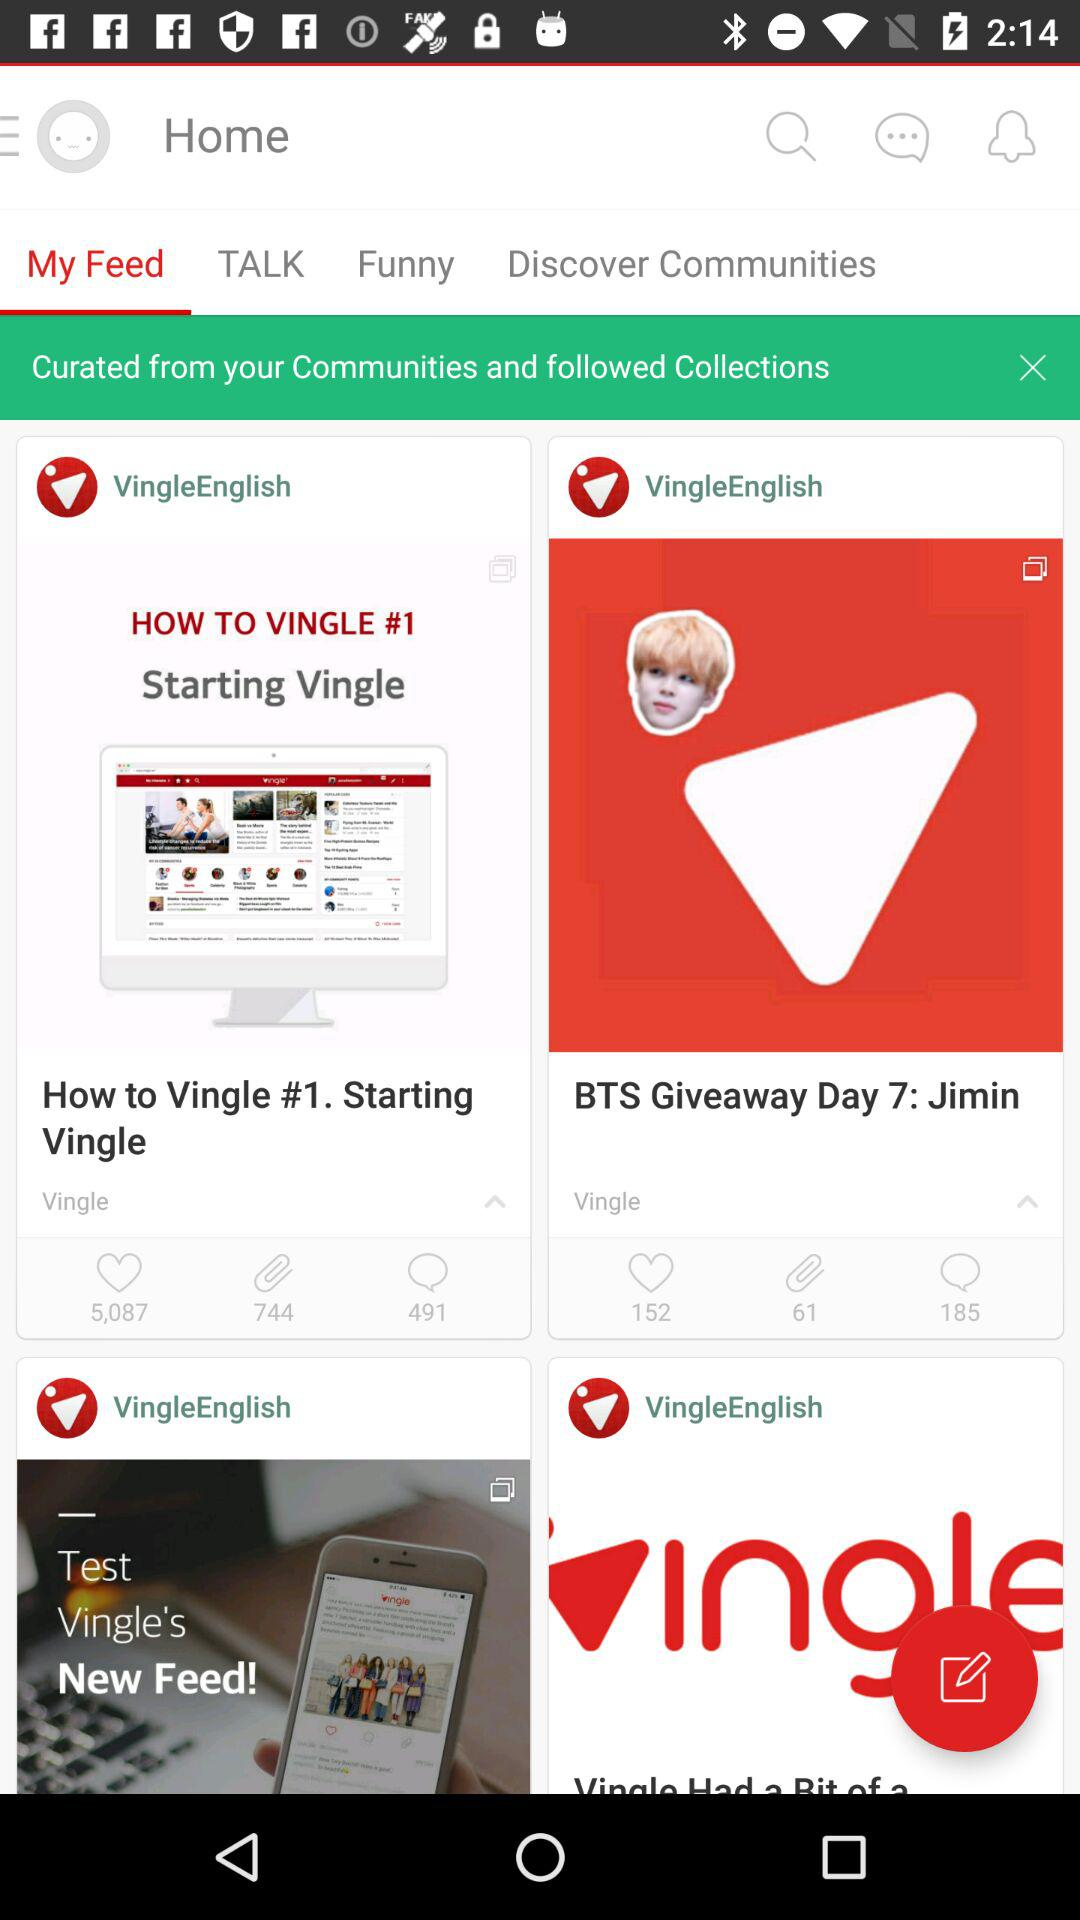Which tab am I on? You are on the "My Feed" tab. 